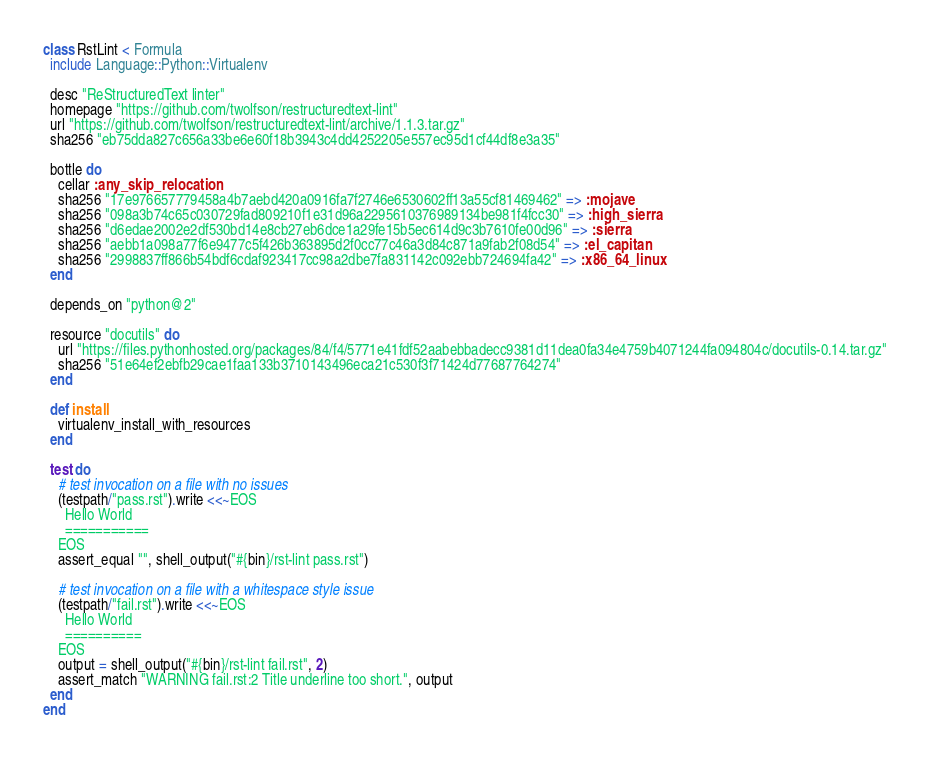Convert code to text. <code><loc_0><loc_0><loc_500><loc_500><_Ruby_>class RstLint < Formula
  include Language::Python::Virtualenv

  desc "ReStructuredText linter"
  homepage "https://github.com/twolfson/restructuredtext-lint"
  url "https://github.com/twolfson/restructuredtext-lint/archive/1.1.3.tar.gz"
  sha256 "eb75dda827c656a33be6e60f18b3943c4dd4252205e557ec95d1cf44df8e3a35"

  bottle do
    cellar :any_skip_relocation
    sha256 "17e976657779458a4b7aebd420a0916fa7f2746e6530602ff13a55cf81469462" => :mojave
    sha256 "098a3b74c65c030729fad809210f1e31d96a2295610376989134be981f4fcc30" => :high_sierra
    sha256 "d6edae2002e2df530bd14e8cb27eb6dce1a29fe15b5ec614d9c3b7610fe00d96" => :sierra
    sha256 "aebb1a098a77f6e9477c5f426b363895d2f0cc77c46a3d84c871a9fab2f08d54" => :el_capitan
    sha256 "2998837ff866b54bdf6cdaf923417cc98a2dbe7fa831142c092ebb724694fa42" => :x86_64_linux
  end

  depends_on "python@2"

  resource "docutils" do
    url "https://files.pythonhosted.org/packages/84/f4/5771e41fdf52aabebbadecc9381d11dea0fa34e4759b4071244fa094804c/docutils-0.14.tar.gz"
    sha256 "51e64ef2ebfb29cae1faa133b3710143496eca21c530f3f71424d77687764274"
  end

  def install
    virtualenv_install_with_resources
  end

  test do
    # test invocation on a file with no issues
    (testpath/"pass.rst").write <<~EOS
      Hello World
      ===========
    EOS
    assert_equal "", shell_output("#{bin}/rst-lint pass.rst")

    # test invocation on a file with a whitespace style issue
    (testpath/"fail.rst").write <<~EOS
      Hello World
      ==========
    EOS
    output = shell_output("#{bin}/rst-lint fail.rst", 2)
    assert_match "WARNING fail.rst:2 Title underline too short.", output
  end
end
</code> 